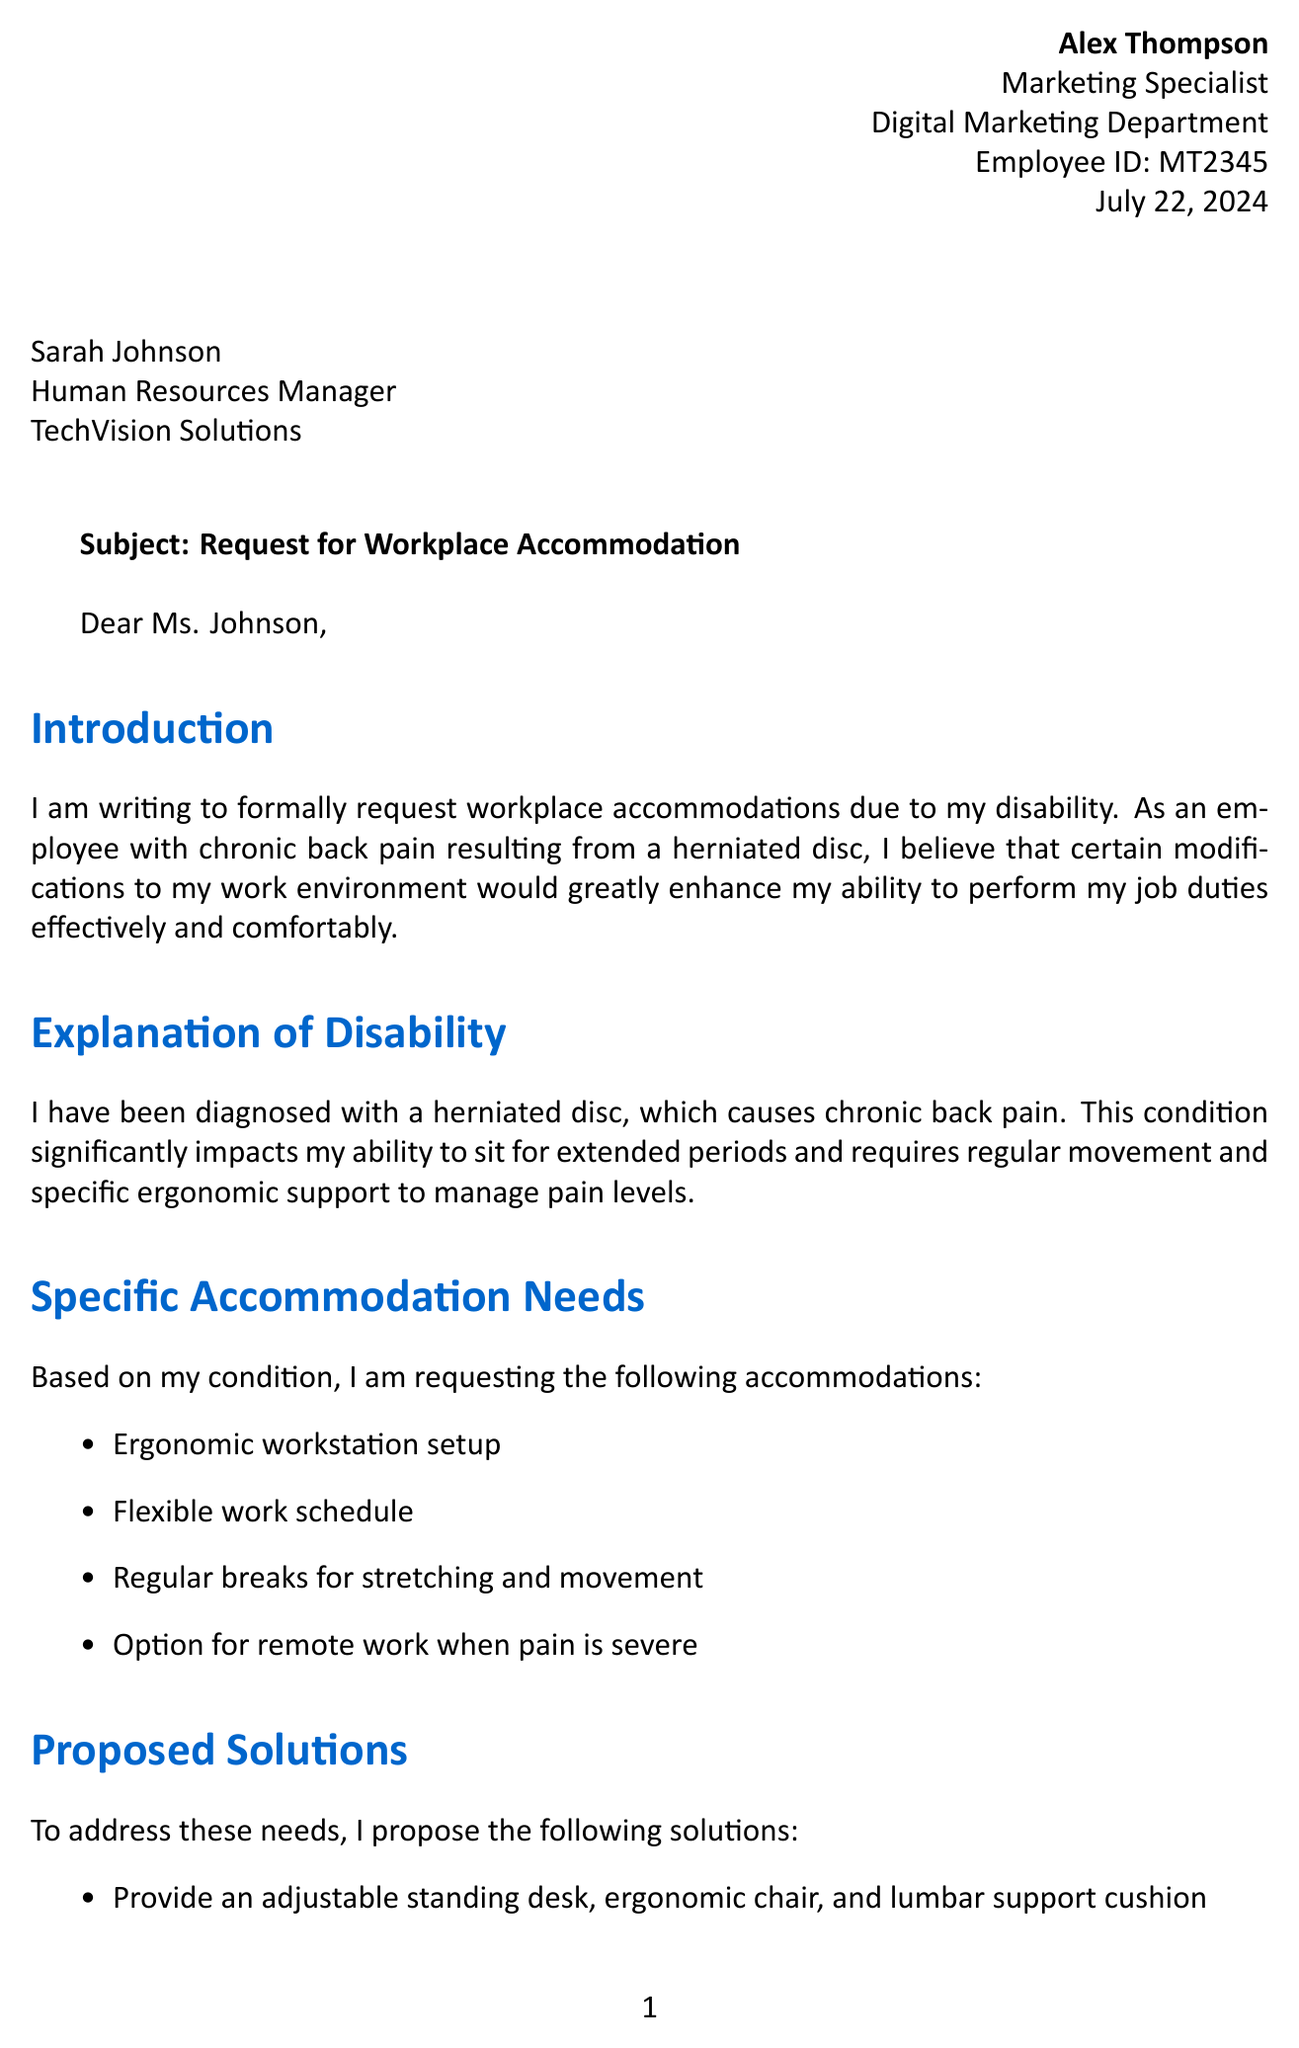What is the employee ID of Alex Thompson? The employee ID is mentioned in the personal details section of the document.
Answer: MT2345 Who is the Human Resources Manager? The document states the name and position of the person to whom the letter is addressed.
Answer: Sarah Johnson What is one of the specific accommodation needs requested? This refers to the list of accommodations detailed in the document.
Answer: Ergonomic workstation setup What is the proposed solution for the flexible work schedule? The solution regarding the flexible work schedule is listed in the proposed solutions section.
Answer: Allow for adjusted start and end times What are the benefits to the company of implementing the requested accommodations? This refers to the list of benefits discussed in the document.
Answer: Increased productivity due to reduced pain and discomfort What is the timeline for implementation of the accommodations? The timeline is specified in the document, indicating when the requested accommodations should begin.
Answer: Within 30 days of approval What is the total cost estimate for the standing desk, ergonomic chair, and lumbar support? This requires summing the costs mentioned in the cost estimates section of the document.
Answer: $850 What law requires employers to provide reasonable accommodations? The relevant legislation mentioned in the document that relates to accommodations is specified.
Answer: Americans with Disabilities Act (ADA) What does the employee express willingness to do regarding solutions? This indicates the attitude of the employee towards the accommodations and flexibility in solutions.
Answer: Open to discussing alternative solutions 